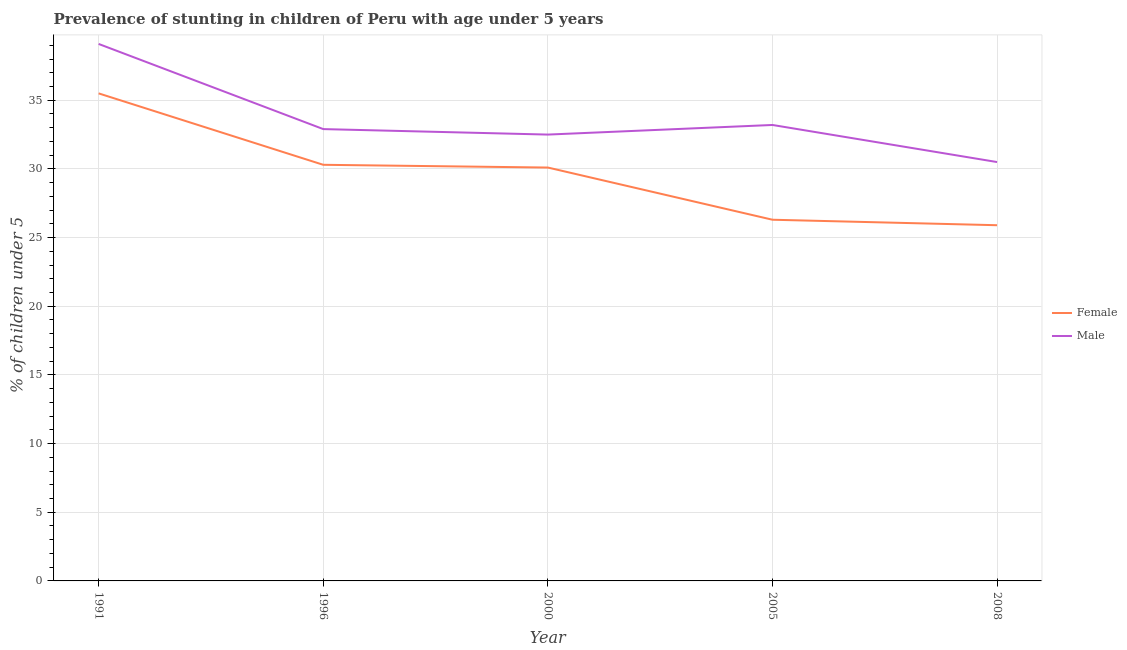How many different coloured lines are there?
Offer a very short reply. 2. Does the line corresponding to percentage of stunted female children intersect with the line corresponding to percentage of stunted male children?
Ensure brevity in your answer.  No. Is the number of lines equal to the number of legend labels?
Ensure brevity in your answer.  Yes. What is the percentage of stunted male children in 1996?
Your answer should be compact. 32.9. Across all years, what is the maximum percentage of stunted female children?
Provide a short and direct response. 35.5. Across all years, what is the minimum percentage of stunted male children?
Your response must be concise. 30.5. In which year was the percentage of stunted female children maximum?
Keep it short and to the point. 1991. In which year was the percentage of stunted female children minimum?
Offer a very short reply. 2008. What is the total percentage of stunted female children in the graph?
Your answer should be very brief. 148.1. What is the difference between the percentage of stunted female children in 1996 and that in 2008?
Your answer should be compact. 4.4. What is the difference between the percentage of stunted male children in 1991 and the percentage of stunted female children in 2000?
Your answer should be compact. 9. What is the average percentage of stunted female children per year?
Make the answer very short. 29.62. In the year 2008, what is the difference between the percentage of stunted female children and percentage of stunted male children?
Provide a short and direct response. -4.6. What is the ratio of the percentage of stunted male children in 2005 to that in 2008?
Your answer should be very brief. 1.09. Is the difference between the percentage of stunted male children in 1991 and 2005 greater than the difference between the percentage of stunted female children in 1991 and 2005?
Provide a short and direct response. No. What is the difference between the highest and the second highest percentage of stunted female children?
Your answer should be compact. 5.2. What is the difference between the highest and the lowest percentage of stunted female children?
Keep it short and to the point. 9.6. In how many years, is the percentage of stunted female children greater than the average percentage of stunted female children taken over all years?
Offer a terse response. 3. Does the percentage of stunted female children monotonically increase over the years?
Provide a short and direct response. No. How many years are there in the graph?
Make the answer very short. 5. Are the values on the major ticks of Y-axis written in scientific E-notation?
Offer a very short reply. No. Where does the legend appear in the graph?
Make the answer very short. Center right. How many legend labels are there?
Provide a succinct answer. 2. What is the title of the graph?
Make the answer very short. Prevalence of stunting in children of Peru with age under 5 years. Does "Grants" appear as one of the legend labels in the graph?
Provide a short and direct response. No. What is the label or title of the X-axis?
Your answer should be very brief. Year. What is the label or title of the Y-axis?
Your response must be concise.  % of children under 5. What is the  % of children under 5 of Female in 1991?
Your answer should be very brief. 35.5. What is the  % of children under 5 in Male in 1991?
Provide a succinct answer. 39.1. What is the  % of children under 5 in Female in 1996?
Ensure brevity in your answer.  30.3. What is the  % of children under 5 of Male in 1996?
Your answer should be very brief. 32.9. What is the  % of children under 5 in Female in 2000?
Make the answer very short. 30.1. What is the  % of children under 5 in Male in 2000?
Make the answer very short. 32.5. What is the  % of children under 5 of Female in 2005?
Your answer should be very brief. 26.3. What is the  % of children under 5 in Male in 2005?
Give a very brief answer. 33.2. What is the  % of children under 5 of Female in 2008?
Make the answer very short. 25.9. What is the  % of children under 5 of Male in 2008?
Your response must be concise. 30.5. Across all years, what is the maximum  % of children under 5 of Female?
Offer a very short reply. 35.5. Across all years, what is the maximum  % of children under 5 in Male?
Your answer should be very brief. 39.1. Across all years, what is the minimum  % of children under 5 in Female?
Keep it short and to the point. 25.9. Across all years, what is the minimum  % of children under 5 in Male?
Provide a short and direct response. 30.5. What is the total  % of children under 5 of Female in the graph?
Provide a succinct answer. 148.1. What is the total  % of children under 5 of Male in the graph?
Offer a very short reply. 168.2. What is the difference between the  % of children under 5 of Male in 1991 and that in 1996?
Your response must be concise. 6.2. What is the difference between the  % of children under 5 in Female in 1991 and that in 2000?
Provide a short and direct response. 5.4. What is the difference between the  % of children under 5 of Male in 1996 and that in 2000?
Your answer should be very brief. 0.4. What is the difference between the  % of children under 5 of Female in 1996 and that in 2005?
Your answer should be very brief. 4. What is the difference between the  % of children under 5 of Male in 1996 and that in 2005?
Give a very brief answer. -0.3. What is the difference between the  % of children under 5 in Female in 1996 and that in 2008?
Your answer should be compact. 4.4. What is the difference between the  % of children under 5 in Female in 2000 and that in 2005?
Give a very brief answer. 3.8. What is the difference between the  % of children under 5 of Female in 2005 and that in 2008?
Give a very brief answer. 0.4. What is the difference between the  % of children under 5 in Female in 1991 and the  % of children under 5 in Male in 2000?
Ensure brevity in your answer.  3. What is the difference between the  % of children under 5 in Female in 1991 and the  % of children under 5 in Male in 2005?
Your answer should be compact. 2.3. What is the difference between the  % of children under 5 of Female in 1996 and the  % of children under 5 of Male in 2000?
Offer a very short reply. -2.2. What is the difference between the  % of children under 5 in Female in 2000 and the  % of children under 5 in Male in 2008?
Provide a succinct answer. -0.4. What is the difference between the  % of children under 5 of Female in 2005 and the  % of children under 5 of Male in 2008?
Your response must be concise. -4.2. What is the average  % of children under 5 in Female per year?
Offer a terse response. 29.62. What is the average  % of children under 5 in Male per year?
Provide a short and direct response. 33.64. In the year 2005, what is the difference between the  % of children under 5 in Female and  % of children under 5 in Male?
Offer a terse response. -6.9. What is the ratio of the  % of children under 5 of Female in 1991 to that in 1996?
Ensure brevity in your answer.  1.17. What is the ratio of the  % of children under 5 of Male in 1991 to that in 1996?
Provide a short and direct response. 1.19. What is the ratio of the  % of children under 5 in Female in 1991 to that in 2000?
Your answer should be compact. 1.18. What is the ratio of the  % of children under 5 of Male in 1991 to that in 2000?
Your answer should be compact. 1.2. What is the ratio of the  % of children under 5 in Female in 1991 to that in 2005?
Your answer should be compact. 1.35. What is the ratio of the  % of children under 5 in Male in 1991 to that in 2005?
Give a very brief answer. 1.18. What is the ratio of the  % of children under 5 of Female in 1991 to that in 2008?
Offer a very short reply. 1.37. What is the ratio of the  % of children under 5 in Male in 1991 to that in 2008?
Keep it short and to the point. 1.28. What is the ratio of the  % of children under 5 of Female in 1996 to that in 2000?
Keep it short and to the point. 1.01. What is the ratio of the  % of children under 5 in Male in 1996 to that in 2000?
Make the answer very short. 1.01. What is the ratio of the  % of children under 5 in Female in 1996 to that in 2005?
Make the answer very short. 1.15. What is the ratio of the  % of children under 5 of Female in 1996 to that in 2008?
Your answer should be very brief. 1.17. What is the ratio of the  % of children under 5 in Male in 1996 to that in 2008?
Keep it short and to the point. 1.08. What is the ratio of the  % of children under 5 of Female in 2000 to that in 2005?
Offer a terse response. 1.14. What is the ratio of the  % of children under 5 of Male in 2000 to that in 2005?
Your response must be concise. 0.98. What is the ratio of the  % of children under 5 of Female in 2000 to that in 2008?
Ensure brevity in your answer.  1.16. What is the ratio of the  % of children under 5 of Male in 2000 to that in 2008?
Make the answer very short. 1.07. What is the ratio of the  % of children under 5 in Female in 2005 to that in 2008?
Your response must be concise. 1.02. What is the ratio of the  % of children under 5 in Male in 2005 to that in 2008?
Provide a succinct answer. 1.09. What is the difference between the highest and the second highest  % of children under 5 in Female?
Your answer should be very brief. 5.2. What is the difference between the highest and the second highest  % of children under 5 of Male?
Your answer should be compact. 5.9. 